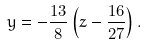Convert formula to latex. <formula><loc_0><loc_0><loc_500><loc_500>y = - \frac { 1 3 } { 8 } \left ( z - \frac { 1 6 } { 2 7 } \right ) .</formula> 